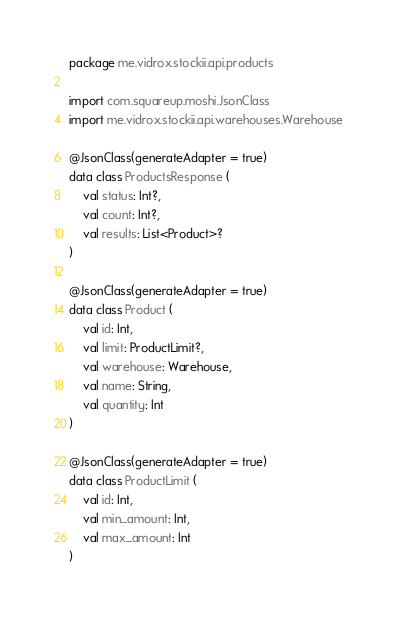<code> <loc_0><loc_0><loc_500><loc_500><_Kotlin_>package me.vidrox.stockii.api.products

import com.squareup.moshi.JsonClass
import me.vidrox.stockii.api.warehouses.Warehouse

@JsonClass(generateAdapter = true)
data class ProductsResponse (
    val status: Int?,
    val count: Int?,
    val results: List<Product>?
)

@JsonClass(generateAdapter = true)
data class Product (
    val id: Int,
    val limit: ProductLimit?,
    val warehouse: Warehouse,
    val name: String,
    val quantity: Int
)

@JsonClass(generateAdapter = true)
data class ProductLimit (
    val id: Int,
    val min_amount: Int,
    val max_amount: Int
)</code> 